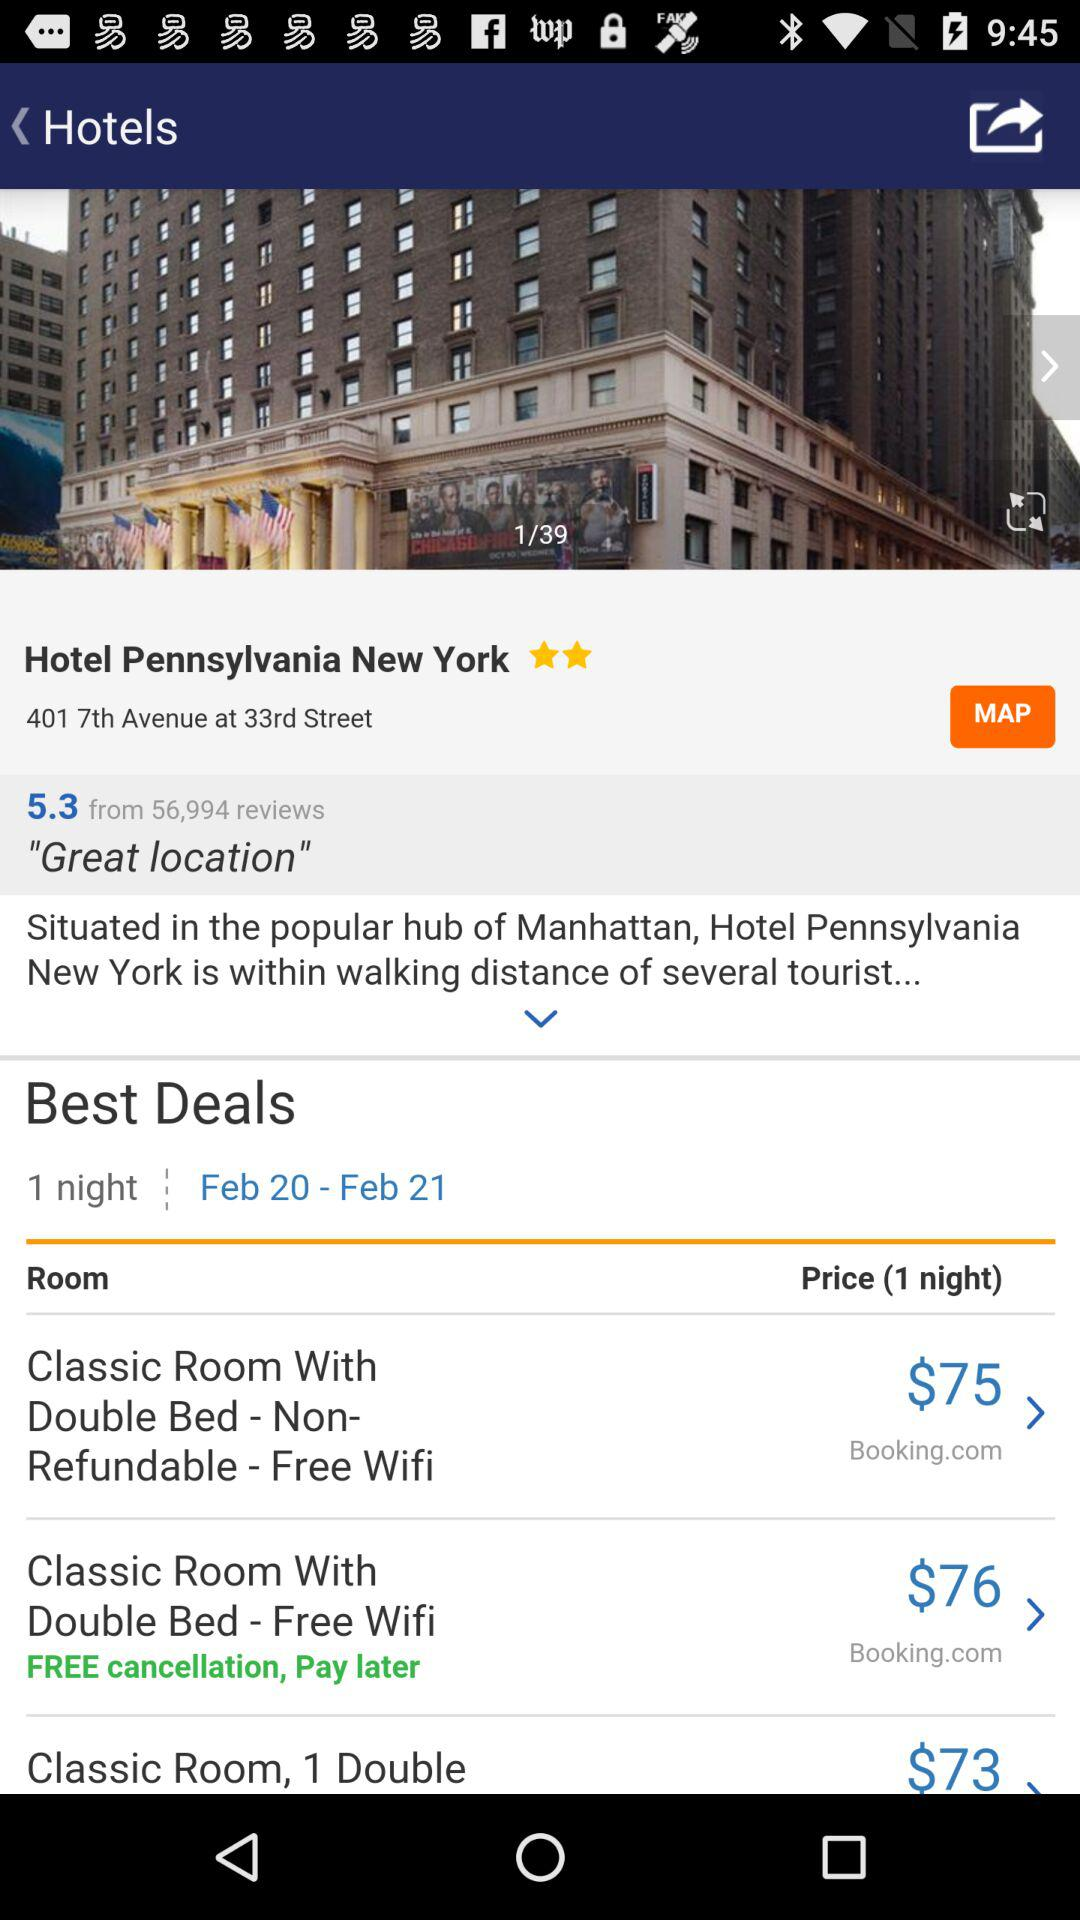For which date rooms are selected?
When the provided information is insufficient, respond with <no answer>. <no answer> 